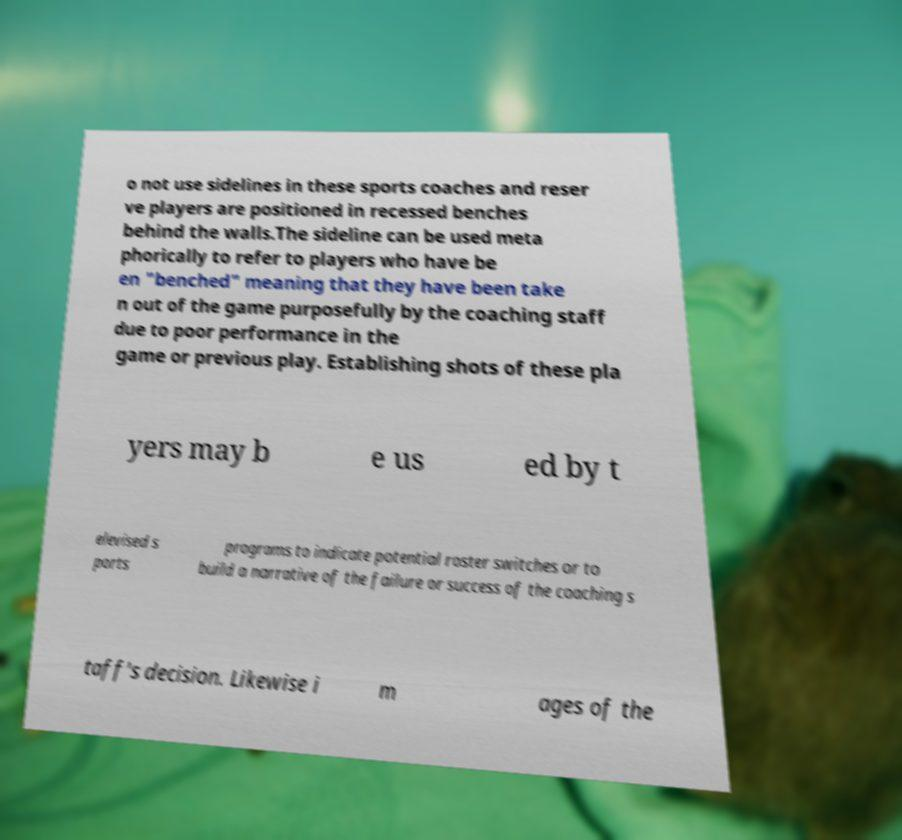Please read and relay the text visible in this image. What does it say? o not use sidelines in these sports coaches and reser ve players are positioned in recessed benches behind the walls.The sideline can be used meta phorically to refer to players who have be en "benched" meaning that they have been take n out of the game purposefully by the coaching staff due to poor performance in the game or previous play. Establishing shots of these pla yers may b e us ed by t elevised s ports programs to indicate potential roster switches or to build a narrative of the failure or success of the coaching s taff's decision. Likewise i m ages of the 